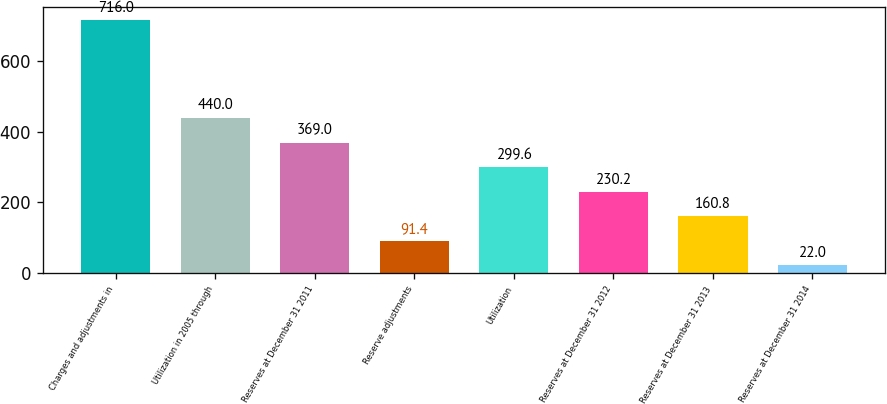<chart> <loc_0><loc_0><loc_500><loc_500><bar_chart><fcel>Charges and adjustments in<fcel>Utilization in 2005 through<fcel>Reserves at December 31 2011<fcel>Reserve adjustments<fcel>Utilization<fcel>Reserves at December 31 2012<fcel>Reserves at December 31 2013<fcel>Reserves at December 31 2014<nl><fcel>716<fcel>440<fcel>369<fcel>91.4<fcel>299.6<fcel>230.2<fcel>160.8<fcel>22<nl></chart> 